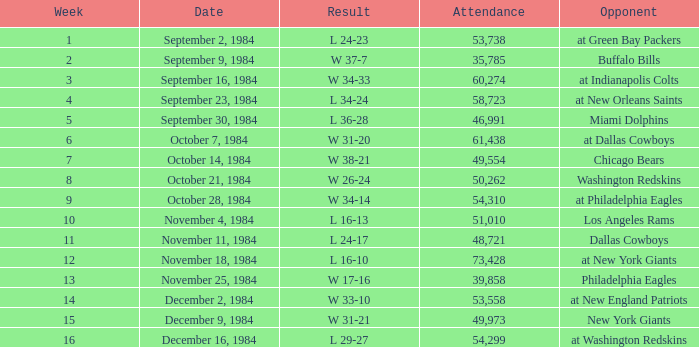What is the sum of attendance when the result was l 16-13? 51010.0. 